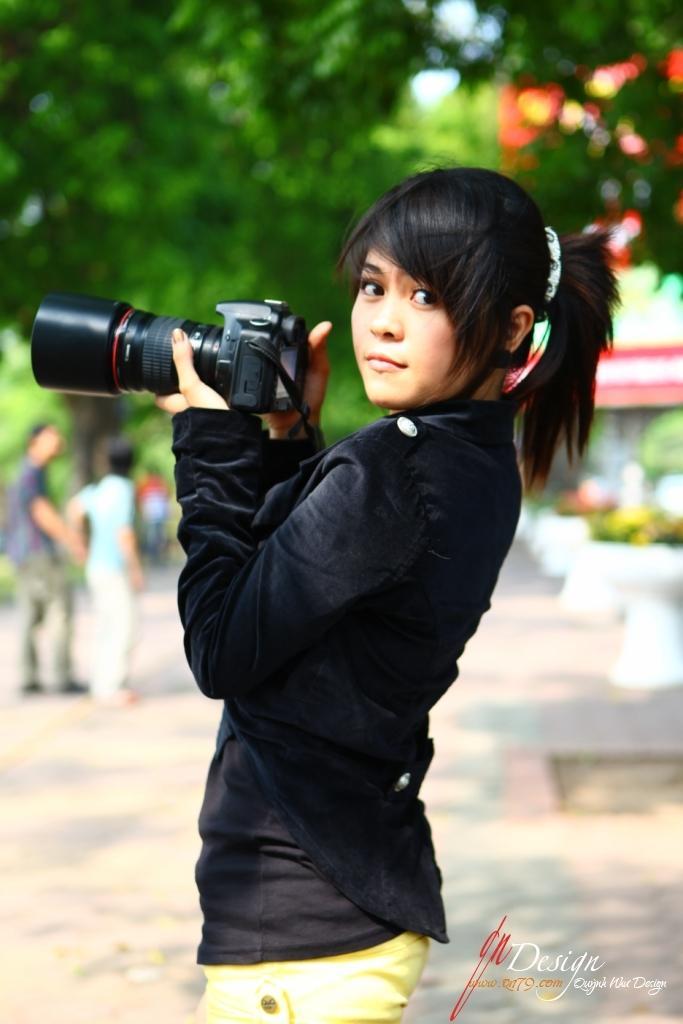How would you summarize this image in a sentence or two? In this image I see a woman, who is holding a camera and she is standing. In the background I can see 3 persons and few trees and the path. 